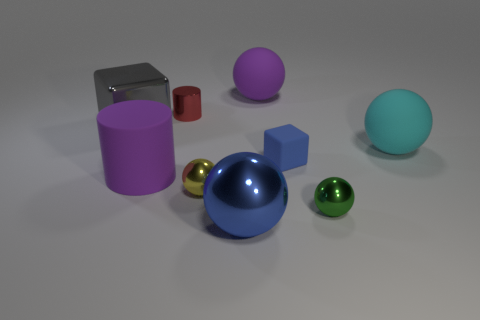What material is the yellow thing that is the same size as the red shiny cylinder?
Give a very brief answer. Metal. What is the material of the large purple object behind the cylinder that is right of the purple object that is in front of the blue matte object?
Your response must be concise. Rubber. The small metal cylinder is what color?
Your answer should be compact. Red. How many small things are gray shiny things or cylinders?
Offer a very short reply. 1. What material is the sphere that is the same color as the rubber cube?
Offer a very short reply. Metal. Are the blue thing behind the big purple cylinder and the big purple thing in front of the tiny red metallic thing made of the same material?
Your answer should be very brief. Yes. Are any tiny blue things visible?
Give a very brief answer. Yes. Are there more big matte objects in front of the tiny red cylinder than metal spheres that are left of the purple cylinder?
Provide a succinct answer. Yes. What material is the other small thing that is the same shape as the tiny green shiny thing?
Keep it short and to the point. Metal. Do the large thing in front of the purple rubber cylinder and the cube that is on the right side of the tiny red object have the same color?
Offer a very short reply. Yes. 